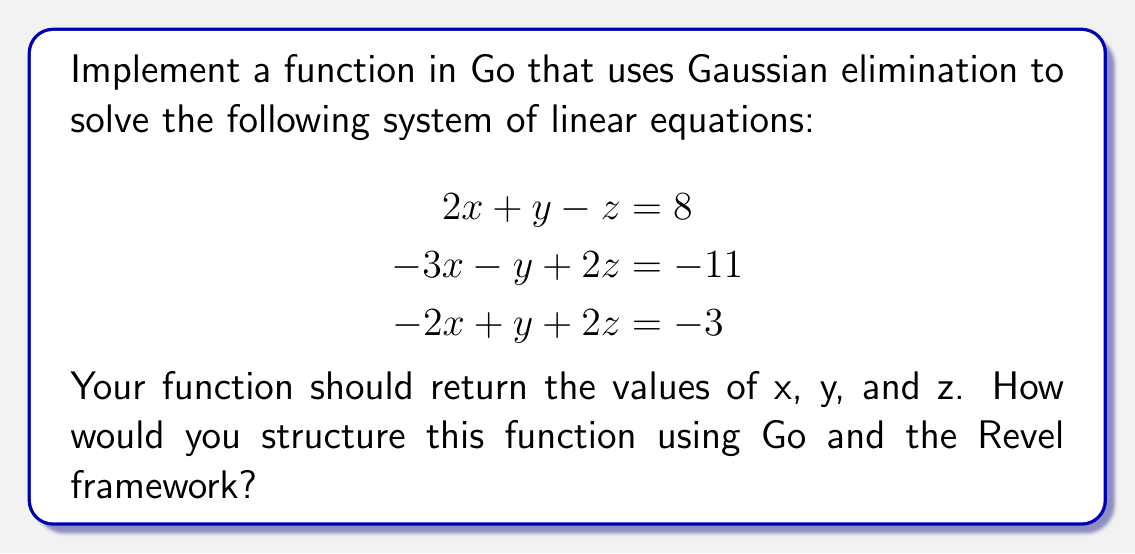Solve this math problem. To solve this problem using Go and the Revel framework, we'll follow these steps:

1. Create a new Revel project and set up a controller to handle the calculation.

2. Implement the Gaussian elimination algorithm in Go:

   a. Create a 2D slice to represent the augmented matrix:
   
   $$
   \begin{bmatrix}
   2 & 1 & -1 & 8 \\
   -3 & -1 & 2 & -11 \\
   -2 & 1 & 2 & -3
   \end{bmatrix}
   $$

   b. Implement forward elimination:
      - For each row, divide by the pivot element
      - Subtract multiples of the current row from all rows below

   c. Implement back substitution to solve for x, y, and z

3. Create a function in the controller:

   ```go
   func (c App) SolveLinearSystem() revel.Result {
       // Implement Gaussian elimination here
       x, y, z := gaussianElimination()
       return c.Render(x, y, z)
   }
   ```

4. Implement the `gaussianElimination` function:

   ```go
   func gaussianElimination() (float64, float64, float64) {
       // Create augmented matrix
       matrix := [][]float64{
           {2, 1, -1, 8},
           {-3, -1, 2, -11},
           {-2, 1, 2, -3},
       }

       // Forward elimination
       for i := 0; i < 3; i++ {
           pivot := matrix[i][i]
           for j := i; j < 4; j++ {
               matrix[i][j] /= pivot
           }
           for k := i + 1; k < 3; k++ {
               factor := matrix[k][i]
               for j := i; j < 4; j++ {
                   matrix[k][j] -= factor * matrix[i][j]
               }
           }
       }

       // Back substitution
       z := matrix[2][3]
       y := matrix[1][3] - matrix[1][2]*z
       x := matrix[0][3] - matrix[0][1]*y - matrix[0][2]*z

       return x, y, z
   }
   ```

5. Create a view template to display the results:

   ```html
   <h1>Solution to the Linear System</h1>
   <p>x = {{.x}}</p>
   <p>y = {{.y}}</p>
   <p>z = {{.z}}</p>
   ```

6. Add a route in the `routes` file to connect the URL to the controller action:

   ```
   GET /solve-linear-system    App.SolveLinearSystem
   ```

This implementation solves the system of linear equations using Gaussian elimination and integrates it into a Revel web application.
Answer: x = 3, y = 2, z = -1 